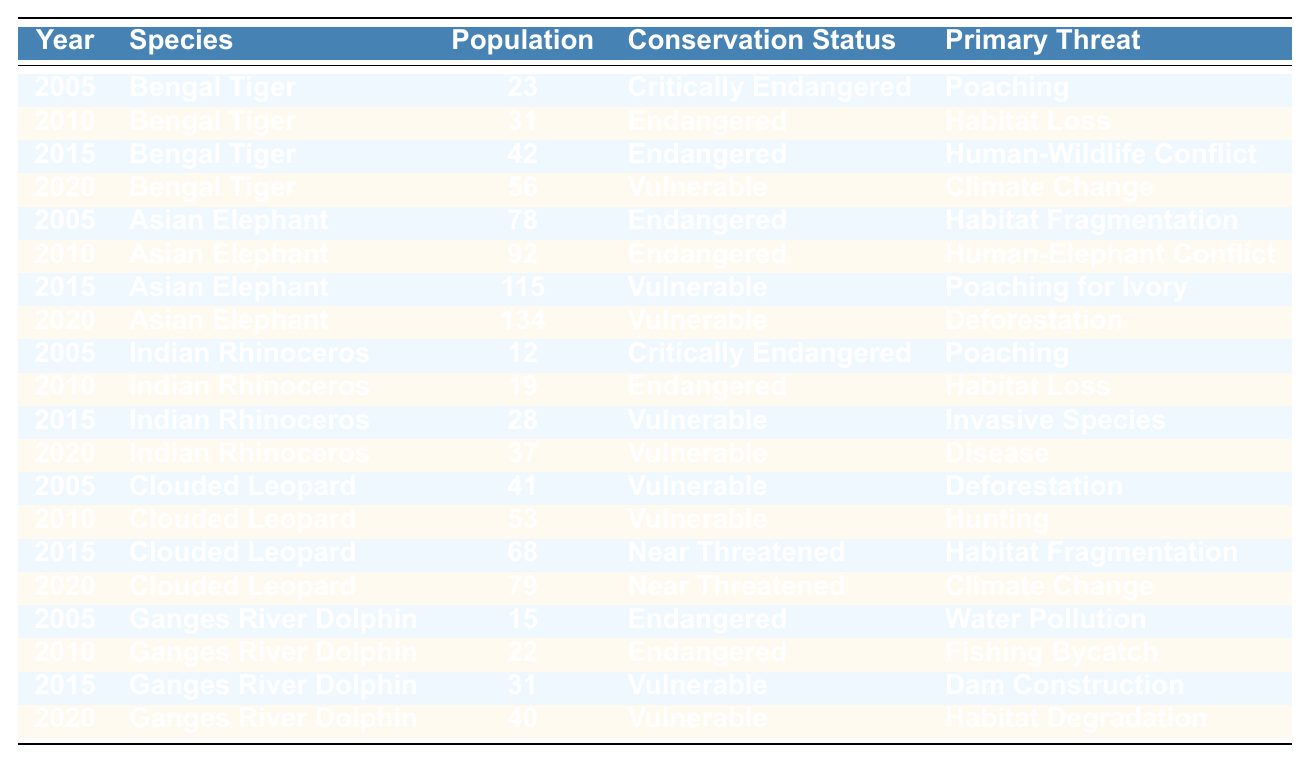What was the population of the Bengal Tiger in 2010? The table indicates that in 2010, the population of the Bengal Tiger was 31.
Answer: 31 What is the conservation status of the Indian Rhinoceros in 2015? In 2015, the Indian Rhinoceros was classified as Vulnerable according to the table.
Answer: Vulnerable How many Asian Elephants were there in total across the years 2005, 2010, 2015, and 2020? Adding the populations of Asian Elephants from 2005 (78), 2010 (92), 2015 (115), and 2020 (134) gives a total of 419.
Answer: 419 Has the population of the Ganges River Dolphin increased from 2015 to 2020? In 2015, the population was 31, and in 2020 it increased to 40, indicating growth.
Answer: Yes Which species saw the greatest increase in population from 2005 to 2020? The Bengal Tiger increased from 23 in 2005 to 56 in 2020, an increase of 33, which is the highest among the species listed.
Answer: Bengal Tiger What is the average population of the Clouded Leopard over the years? The population numbers are 41 (2005), 53 (2010), 68 (2015), and 79 (2020). The sum is 241, and dividing by 4 gives an average of 60.25.
Answer: 60.25 Were any species classified as Critically Endangered in 2020? The table shows that the only species classified as Critically Endangered in 2020 was the Indian Rhinoceros; it was actually Vulnerable that year.
Answer: No How many species have moved from a more endangered status to a less endangered status from 2005 to 2020? The Bengal Tiger and Asian Elephant improved their status from Critically Endangered/Endangered to Vulnerable. Thus, two species changed to a less endangered status.
Answer: 2 Did the population of the Asian Elephant increase by more than 50 individuals between 2005 and 2020? The population increased from 78 in 2005 to 134 in 2020, which is an increase of 56 individuals, indicating that it did exceed 50.
Answer: Yes What was the primary threat for the Indian Rhinoceros in 2015? The primary threat listed for the Indian Rhinoceros in 2015 was Invasive Species as per the data in the table.
Answer: Invasive Species 